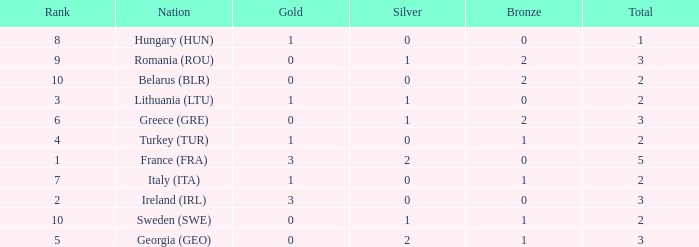What are the most bronze medals in a rank more than 1 with a total larger than 3? None. 